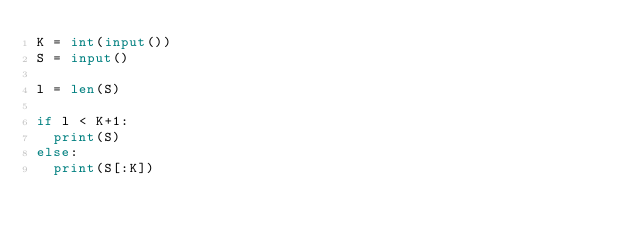Convert code to text. <code><loc_0><loc_0><loc_500><loc_500><_Python_>K = int(input())
S = input()

l = len(S)

if l < K+1:
  print(S)
else:
  print(S[:K])</code> 